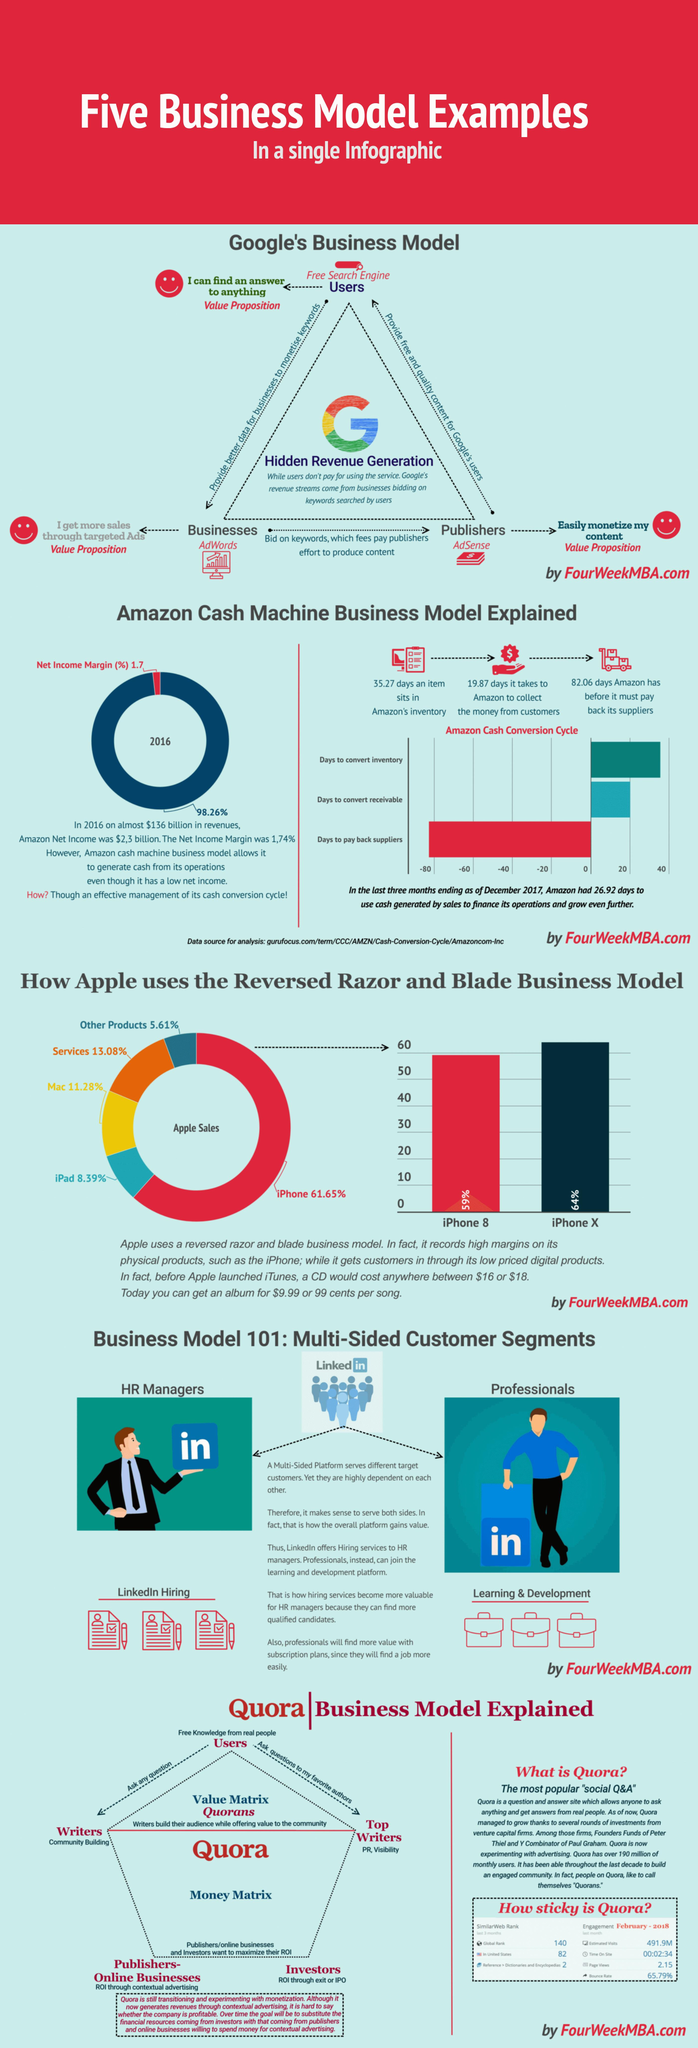Mention a couple of crucial points in this snapshot. The item has been sitting in Amazon's inventory for approximately 35 days. Amazon took approximately 19.87 days on average to collect payment from its customers. 